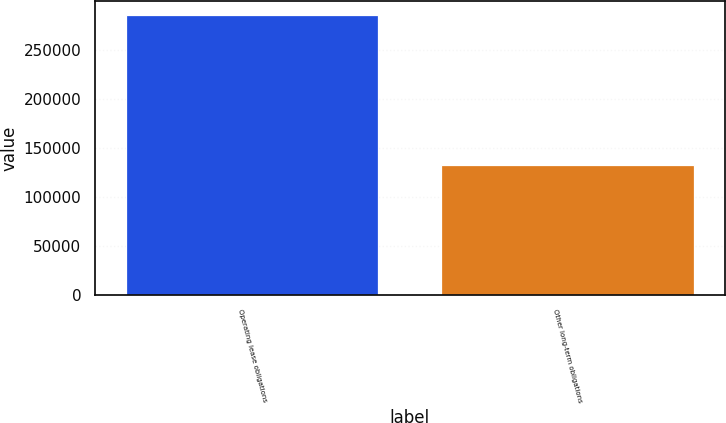<chart> <loc_0><loc_0><loc_500><loc_500><bar_chart><fcel>Operating lease obligations<fcel>Other long-term obligations<nl><fcel>285633<fcel>132716<nl></chart> 